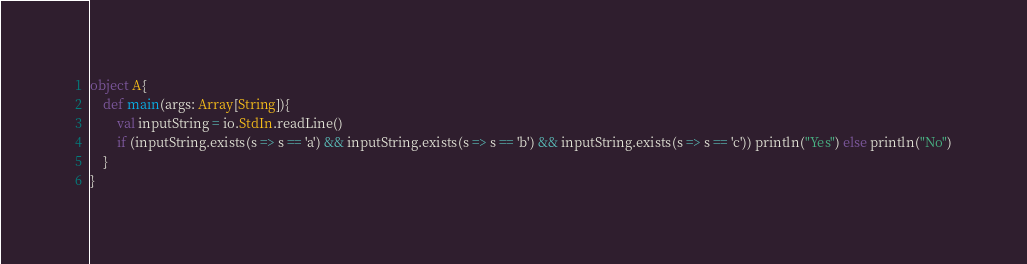<code> <loc_0><loc_0><loc_500><loc_500><_Scala_>object A{
    def main(args: Array[String]){
        val inputString = io.StdIn.readLine()
        if (inputString.exists(s => s == 'a') && inputString.exists(s => s == 'b') && inputString.exists(s => s == 'c')) println("Yes") else println("No")
    }
}</code> 